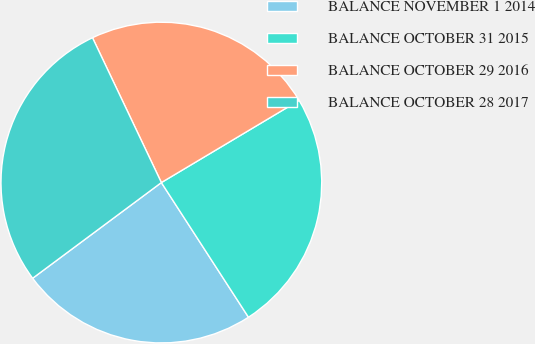Convert chart to OTSL. <chart><loc_0><loc_0><loc_500><loc_500><pie_chart><fcel>BALANCE NOVEMBER 1 2014<fcel>BALANCE OCTOBER 31 2015<fcel>BALANCE OCTOBER 29 2016<fcel>BALANCE OCTOBER 28 2017<nl><fcel>23.96%<fcel>24.42%<fcel>23.5%<fcel>28.11%<nl></chart> 